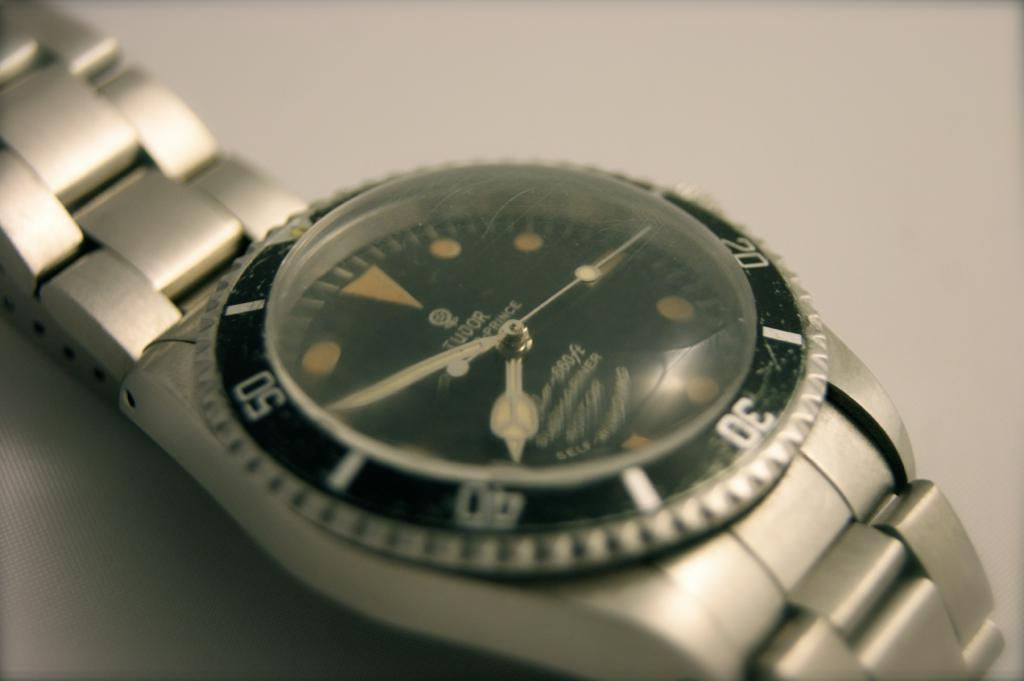<image>
Write a terse but informative summary of the picture. A Tudor watch has the time of about 7:50. 